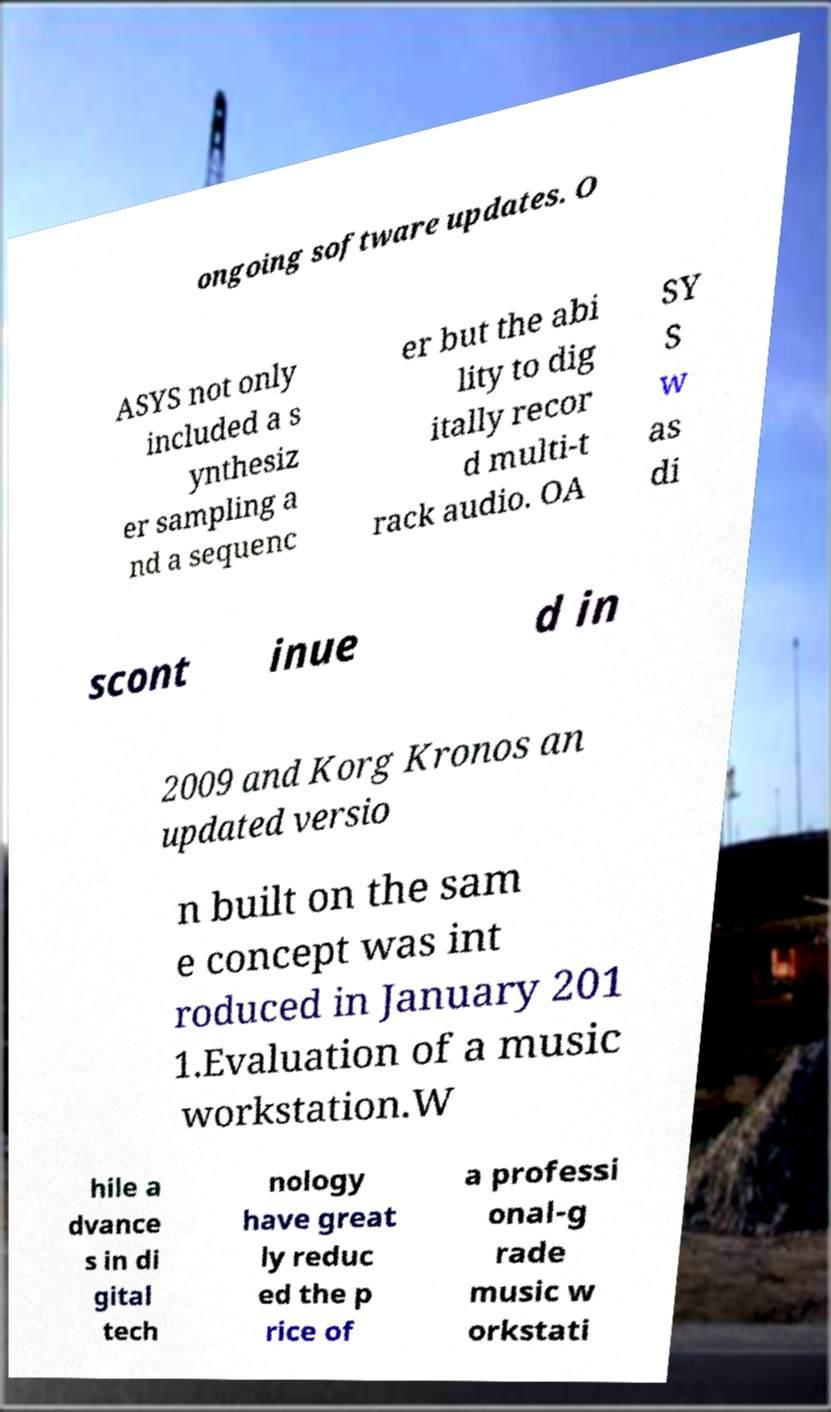For documentation purposes, I need the text within this image transcribed. Could you provide that? ongoing software updates. O ASYS not only included a s ynthesiz er sampling a nd a sequenc er but the abi lity to dig itally recor d multi-t rack audio. OA SY S w as di scont inue d in 2009 and Korg Kronos an updated versio n built on the sam e concept was int roduced in January 201 1.Evaluation of a music workstation.W hile a dvance s in di gital tech nology have great ly reduc ed the p rice of a professi onal-g rade music w orkstati 